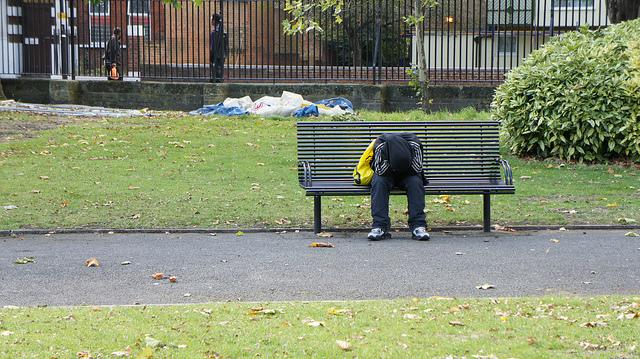Where is the head of this person? in lap 